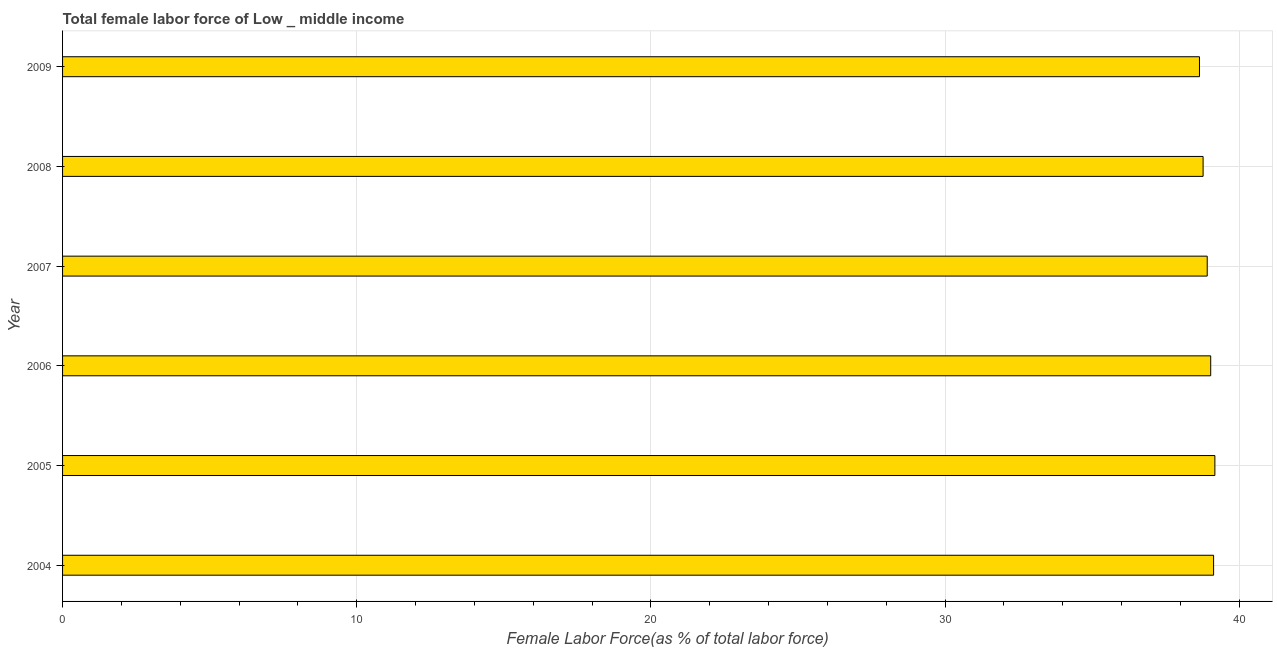Does the graph contain any zero values?
Keep it short and to the point. No. Does the graph contain grids?
Ensure brevity in your answer.  Yes. What is the title of the graph?
Your response must be concise. Total female labor force of Low _ middle income. What is the label or title of the X-axis?
Offer a very short reply. Female Labor Force(as % of total labor force). What is the label or title of the Y-axis?
Provide a short and direct response. Year. What is the total female labor force in 2009?
Offer a terse response. 38.65. Across all years, what is the maximum total female labor force?
Provide a short and direct response. 39.17. Across all years, what is the minimum total female labor force?
Your answer should be very brief. 38.65. What is the sum of the total female labor force?
Provide a short and direct response. 233.67. What is the difference between the total female labor force in 2007 and 2008?
Your response must be concise. 0.14. What is the average total female labor force per year?
Your response must be concise. 38.95. What is the median total female labor force?
Keep it short and to the point. 38.97. In how many years, is the total female labor force greater than 2 %?
Offer a terse response. 6. What is the ratio of the total female labor force in 2005 to that in 2007?
Make the answer very short. 1.01. Is the difference between the total female labor force in 2005 and 2006 greater than the difference between any two years?
Your response must be concise. No. What is the difference between the highest and the second highest total female labor force?
Your response must be concise. 0.04. Is the sum of the total female labor force in 2004 and 2005 greater than the maximum total female labor force across all years?
Provide a succinct answer. Yes. What is the difference between the highest and the lowest total female labor force?
Offer a very short reply. 0.52. In how many years, is the total female labor force greater than the average total female labor force taken over all years?
Give a very brief answer. 3. How many bars are there?
Your answer should be very brief. 6. How many years are there in the graph?
Your answer should be compact. 6. What is the difference between two consecutive major ticks on the X-axis?
Your answer should be compact. 10. What is the Female Labor Force(as % of total labor force) of 2004?
Give a very brief answer. 39.13. What is the Female Labor Force(as % of total labor force) in 2005?
Offer a terse response. 39.17. What is the Female Labor Force(as % of total labor force) in 2006?
Provide a succinct answer. 39.03. What is the Female Labor Force(as % of total labor force) in 2007?
Give a very brief answer. 38.91. What is the Female Labor Force(as % of total labor force) of 2008?
Your answer should be compact. 38.77. What is the Female Labor Force(as % of total labor force) in 2009?
Provide a short and direct response. 38.65. What is the difference between the Female Labor Force(as % of total labor force) in 2004 and 2005?
Provide a succinct answer. -0.04. What is the difference between the Female Labor Force(as % of total labor force) in 2004 and 2006?
Offer a very short reply. 0.1. What is the difference between the Female Labor Force(as % of total labor force) in 2004 and 2007?
Offer a very short reply. 0.22. What is the difference between the Female Labor Force(as % of total labor force) in 2004 and 2008?
Make the answer very short. 0.36. What is the difference between the Female Labor Force(as % of total labor force) in 2004 and 2009?
Provide a short and direct response. 0.48. What is the difference between the Female Labor Force(as % of total labor force) in 2005 and 2006?
Your answer should be compact. 0.14. What is the difference between the Female Labor Force(as % of total labor force) in 2005 and 2007?
Make the answer very short. 0.26. What is the difference between the Female Labor Force(as % of total labor force) in 2005 and 2008?
Offer a very short reply. 0.4. What is the difference between the Female Labor Force(as % of total labor force) in 2005 and 2009?
Ensure brevity in your answer.  0.52. What is the difference between the Female Labor Force(as % of total labor force) in 2006 and 2007?
Ensure brevity in your answer.  0.12. What is the difference between the Female Labor Force(as % of total labor force) in 2006 and 2008?
Provide a short and direct response. 0.26. What is the difference between the Female Labor Force(as % of total labor force) in 2006 and 2009?
Provide a succinct answer. 0.38. What is the difference between the Female Labor Force(as % of total labor force) in 2007 and 2008?
Your answer should be very brief. 0.14. What is the difference between the Female Labor Force(as % of total labor force) in 2007 and 2009?
Provide a succinct answer. 0.26. What is the difference between the Female Labor Force(as % of total labor force) in 2008 and 2009?
Your response must be concise. 0.12. What is the ratio of the Female Labor Force(as % of total labor force) in 2004 to that in 2005?
Offer a terse response. 1. What is the ratio of the Female Labor Force(as % of total labor force) in 2005 to that in 2007?
Ensure brevity in your answer.  1.01. What is the ratio of the Female Labor Force(as % of total labor force) in 2005 to that in 2009?
Give a very brief answer. 1.01. What is the ratio of the Female Labor Force(as % of total labor force) in 2006 to that in 2007?
Give a very brief answer. 1. What is the ratio of the Female Labor Force(as % of total labor force) in 2006 to that in 2008?
Your answer should be very brief. 1.01. What is the ratio of the Female Labor Force(as % of total labor force) in 2006 to that in 2009?
Ensure brevity in your answer.  1.01. What is the ratio of the Female Labor Force(as % of total labor force) in 2008 to that in 2009?
Your answer should be compact. 1. 